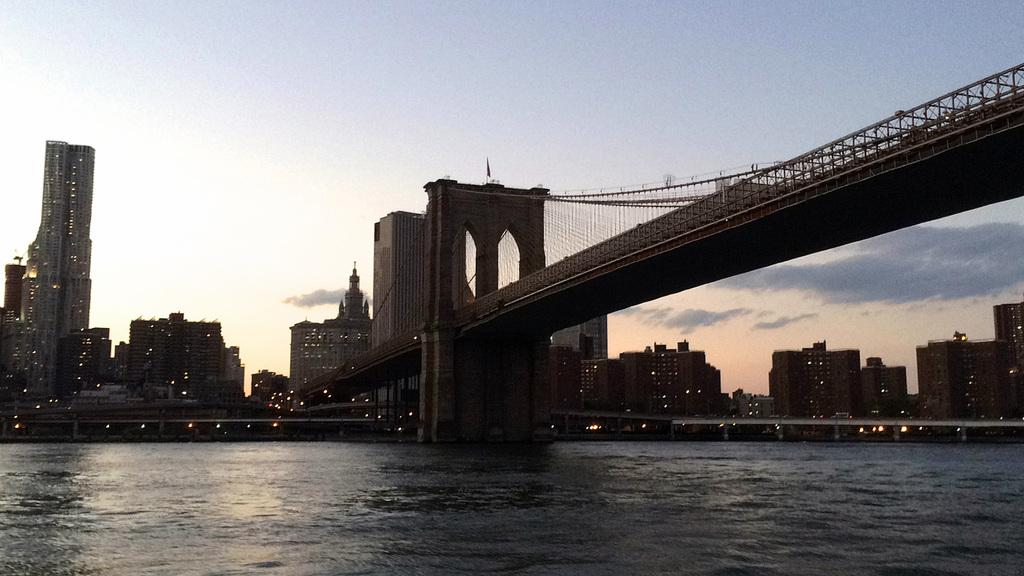What is the primary element visible in the image? There is water in the image. What structure can be seen above the water in the right corner of the image? There is a bridge above the water in the right corner of the image. What can be seen in the distance in the image? There are buildings in the background of the image. How many fairies are flying over the water in the image? There are no fairies present in the image; it only features water, a bridge, and buildings in the background. 